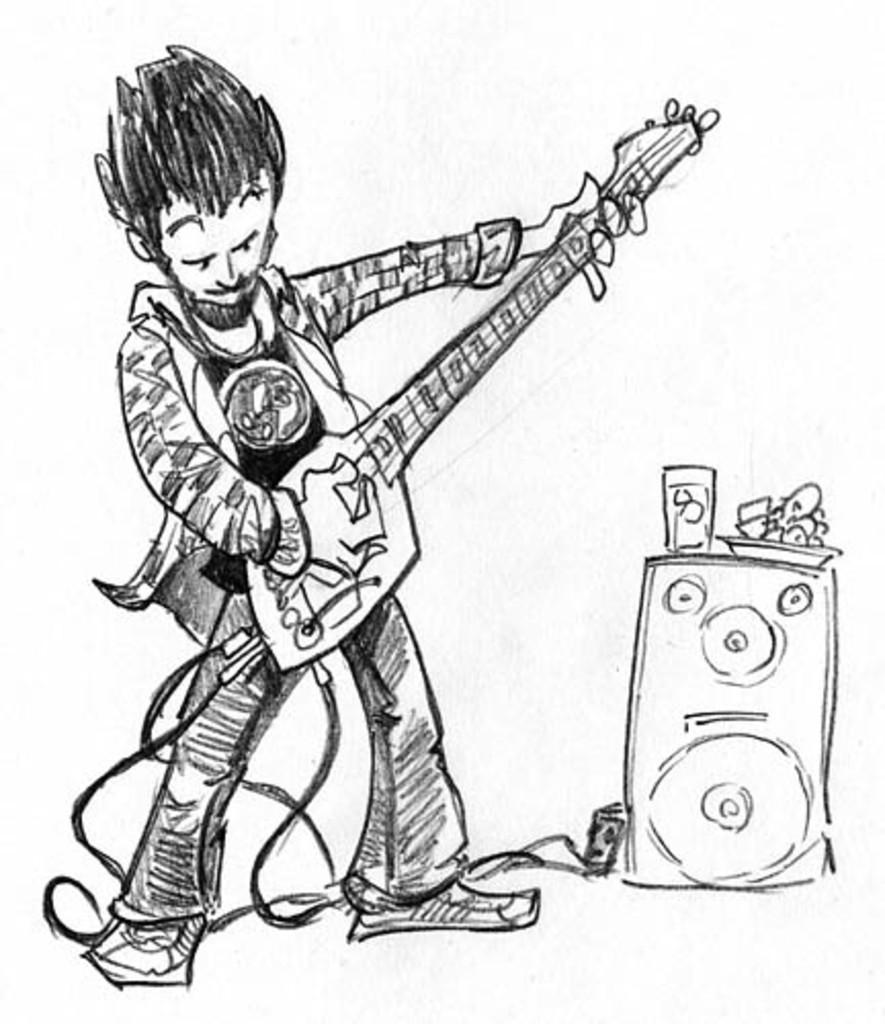What type of artwork is shown in the image? The image is a painting. What is the main subject of the painting? The painting depicts a person playing a guitar. What other object can be seen in the painting? There is a speaker in the painting. Are there any other elements in the painting besides the person and the speaker? Yes, there are objects present in the painting. What historical event is depicted in the painting? The painting does not depict any historical event; it shows a person playing a guitar and a speaker. Can you tell me how many forks are visible in the painting? There are no forks present in the painting; it features a person playing a guitar, a speaker, and other unspecified objects. 